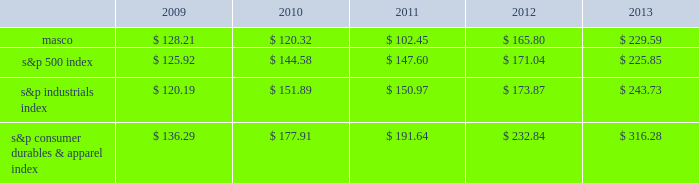6feb201418202649 performance graph the table below compares the cumulative total shareholder return on our common stock with the cumulative total return of ( i ) the standard & poor 2019s 500 composite stock index ( 2018 2018s&p 500 index 2019 2019 ) , ( ii ) the standard & poor 2019s industrials index ( 2018 2018s&p industrials index 2019 2019 ) and ( iii ) the standard & poor 2019s consumer durables & apparel index ( 2018 2018s&p consumer durables & apparel index 2019 2019 ) , from december 31 , 2008 through december 31 , 2013 , when the closing price of our common stock was $ 22.77 .
The graph assumes investments of $ 100 on december 31 , 2008 in our common stock and in each of the three indices and the reinvestment of dividends .
$ 350.00 $ 300.00 $ 250.00 $ 200.00 $ 150.00 $ 100.00 $ 50.00 performance graph .
In july 2007 , our board of directors authorized the purchase of up to 50 million shares of our common stock in open-market transactions or otherwise .
At december 31 , 2013 , we had remaining authorization to repurchase up to 22.6 million shares .
During the first quarter of 2013 , we repurchased and retired 1.7 million shares of our common stock , for cash aggregating $ 35 million to offset the dilutive impact of the 2013 grant of 1.7 million shares of long-term stock awards .
We have not purchased any shares since march 2013. .
What was the percentage cumulative total shareholder return on masco common stock for the five year period ended 2013? 
Computations: ((229.59 - 100) / 100)
Answer: 1.2959. 